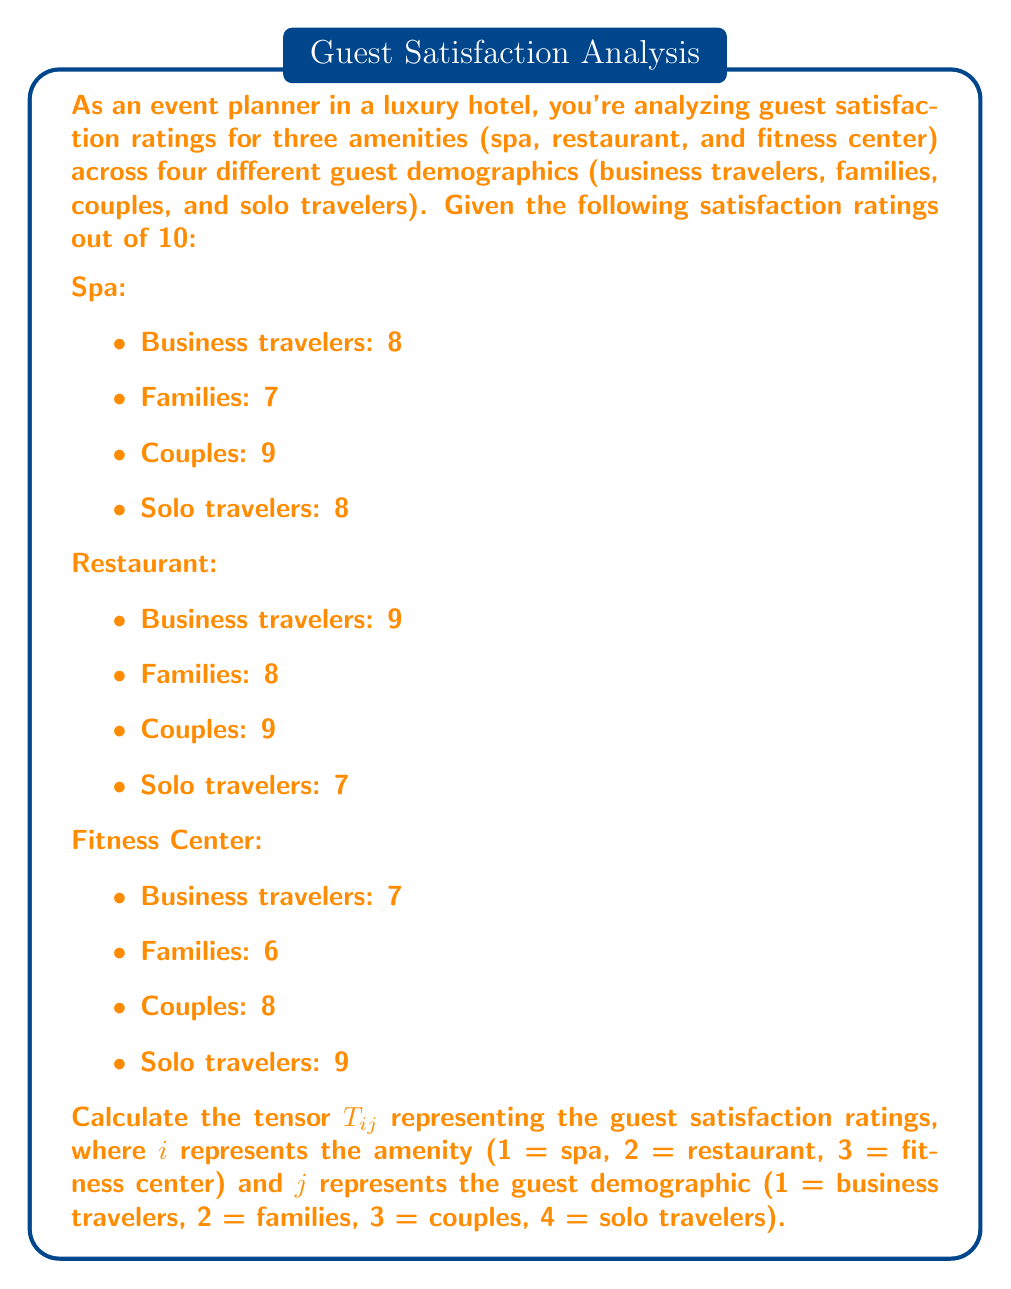Solve this math problem. To solve this problem, we need to organize the given data into a tensor format. A tensor is a mathematical object that can be represented as a multi-dimensional array. In this case, we have a 2-dimensional tensor (or matrix) where the rows represent amenities and the columns represent guest demographics.

Step 1: Identify the tensor dimensions
- $i$ (rows) represents amenities (1 = spa, 2 = restaurant, 3 = fitness center)
- $j$ (columns) represents guest demographics (1 = business travelers, 2 = families, 3 = couples, 4 = solo travelers)

Step 2: Construct the tensor $T_{ij}$
We'll create a 3x4 matrix using the given satisfaction ratings:

$$T_{ij} = \begin{bmatrix}
8 & 7 & 9 & 8 \\
9 & 8 & 9 & 7 \\
7 & 6 & 8 & 9
\end{bmatrix}$$

Where:
- The first row represents spa ratings
- The second row represents restaurant ratings
- The third row represents fitness center ratings
- Each column represents a guest demographic in the order: business travelers, families, couples, solo travelers

Step 3: Verify the tensor elements
Let's confirm a few elements to ensure correct placement:
- $T_{11} = 8$ (spa rating for business travelers)
- $T_{23} = 9$ (restaurant rating for couples)
- $T_{34} = 9$ (fitness center rating for solo travelers)

The tensor $T_{ij}$ now accurately represents the guest satisfaction ratings for multiple hotel amenities across different guest demographics.
Answer: $$T_{ij} = \begin{bmatrix}
8 & 7 & 9 & 8 \\
9 & 8 & 9 & 7 \\
7 & 6 & 8 & 9
\end{bmatrix}$$ 